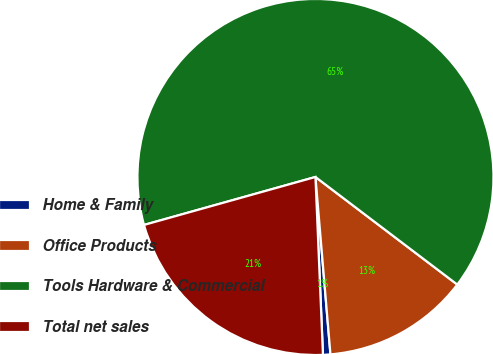Convert chart. <chart><loc_0><loc_0><loc_500><loc_500><pie_chart><fcel>Home & Family<fcel>Office Products<fcel>Tools Hardware & Commercial<fcel>Total net sales<nl><fcel>0.67%<fcel>13.33%<fcel>64.67%<fcel>21.33%<nl></chart> 